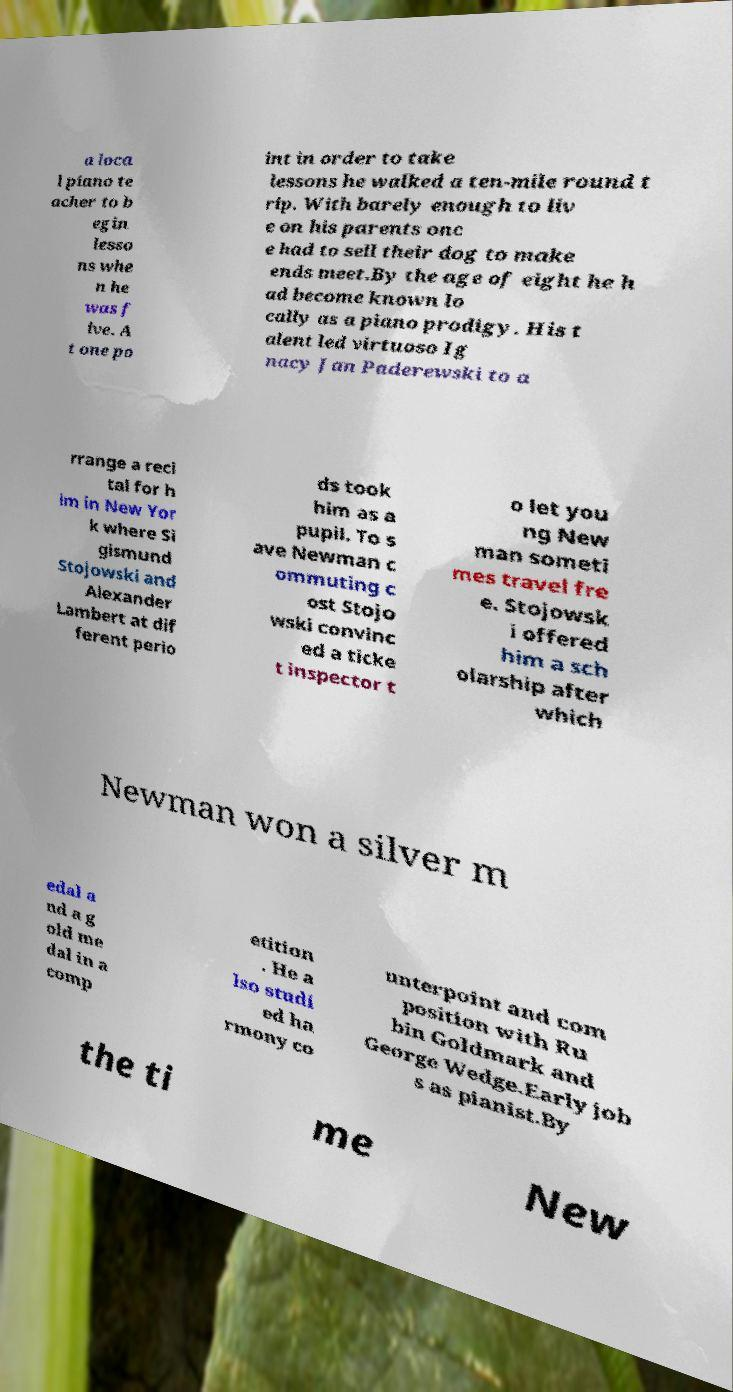Please read and relay the text visible in this image. What does it say? a loca l piano te acher to b egin lesso ns whe n he was f ive. A t one po int in order to take lessons he walked a ten-mile round t rip. With barely enough to liv e on his parents onc e had to sell their dog to make ends meet.By the age of eight he h ad become known lo cally as a piano prodigy. His t alent led virtuoso Ig nacy Jan Paderewski to a rrange a reci tal for h im in New Yor k where Si gismund Stojowski and Alexander Lambert at dif ferent perio ds took him as a pupil. To s ave Newman c ommuting c ost Stojo wski convinc ed a ticke t inspector t o let you ng New man someti mes travel fre e. Stojowsk i offered him a sch olarship after which Newman won a silver m edal a nd a g old me dal in a comp etition . He a lso studi ed ha rmony co unterpoint and com position with Ru bin Goldmark and George Wedge.Early job s as pianist.By the ti me New 